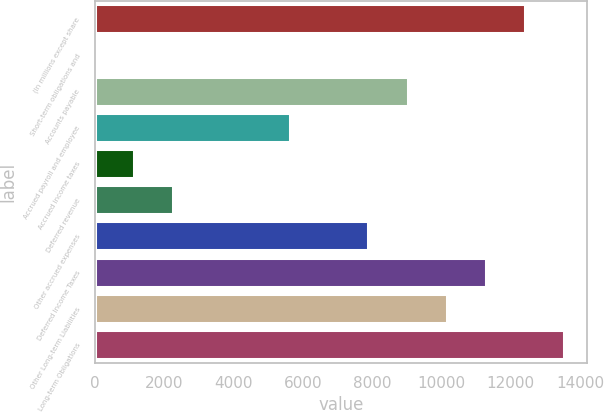<chart> <loc_0><loc_0><loc_500><loc_500><bar_chart><fcel>(In millions except share<fcel>Short-term obligations and<fcel>Accounts payable<fcel>Accrued payroll and employee<fcel>Accrued income taxes<fcel>Deferred revenue<fcel>Other accrued expenses<fcel>Deferred Income Taxes<fcel>Other Long-term Liabilities<fcel>Long-term Obligations<nl><fcel>12399<fcel>14.8<fcel>9021.52<fcel>5644<fcel>1140.64<fcel>2266.48<fcel>7895.68<fcel>11273.2<fcel>10147.4<fcel>13524.9<nl></chart> 